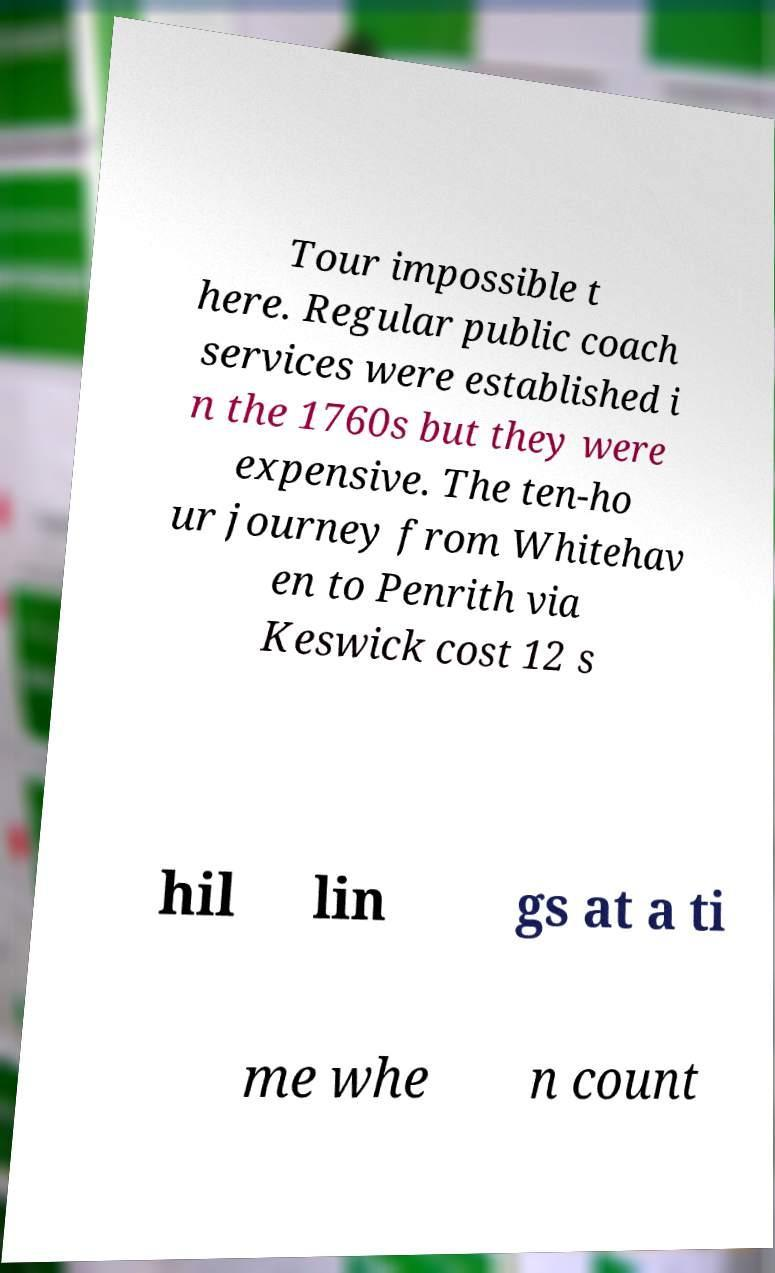Please read and relay the text visible in this image. What does it say? Tour impossible t here. Regular public coach services were established i n the 1760s but they were expensive. The ten-ho ur journey from Whitehav en to Penrith via Keswick cost 12 s hil lin gs at a ti me whe n count 